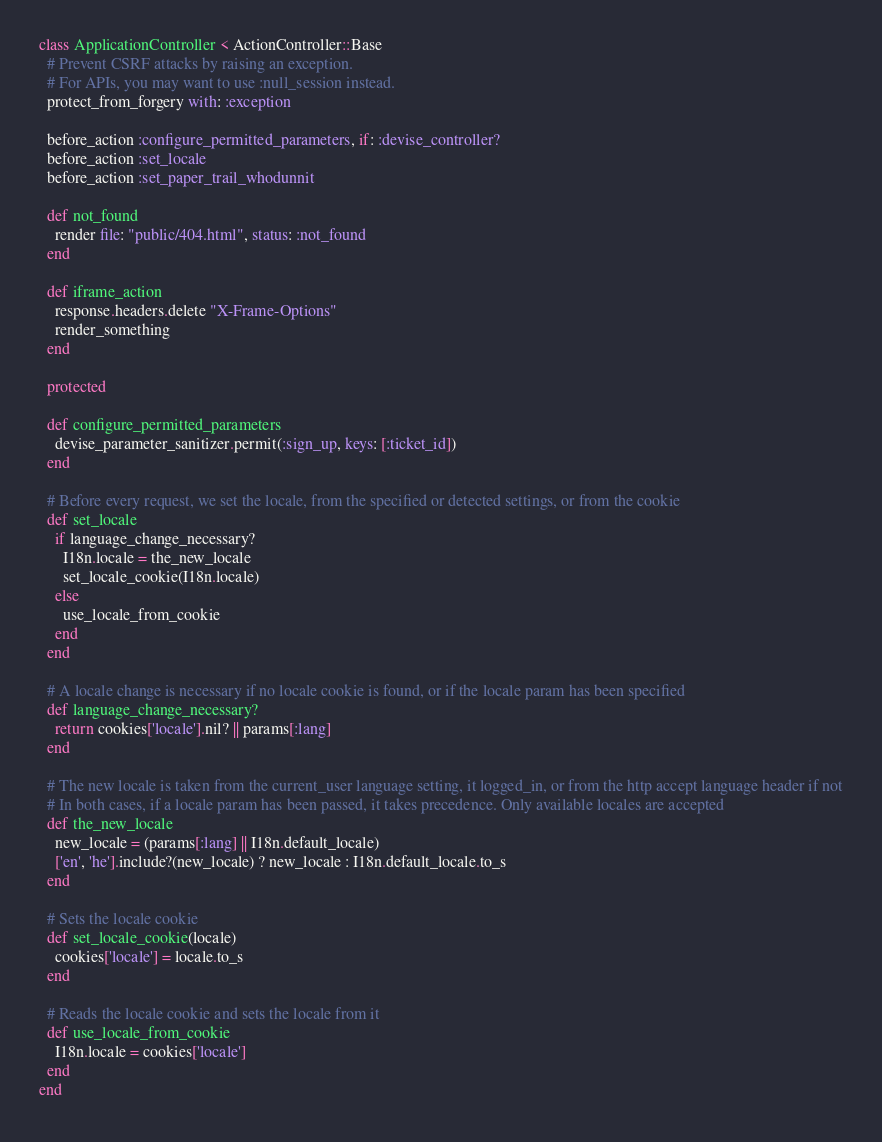<code> <loc_0><loc_0><loc_500><loc_500><_Ruby_>class ApplicationController < ActionController::Base
  # Prevent CSRF attacks by raising an exception.
  # For APIs, you may want to use :null_session instead.
  protect_from_forgery with: :exception

  before_action :configure_permitted_parameters, if: :devise_controller?
  before_action :set_locale
  before_action :set_paper_trail_whodunnit

  def not_found
    render file: "public/404.html", status: :not_found
  end

  def iframe_action
    response.headers.delete "X-Frame-Options"
    render_something
  end
  
  protected

  def configure_permitted_parameters
    devise_parameter_sanitizer.permit(:sign_up, keys: [:ticket_id])
  end
  
  # Before every request, we set the locale, from the specified or detected settings, or from the cookie
  def set_locale
    if language_change_necessary?
      I18n.locale = the_new_locale
      set_locale_cookie(I18n.locale)
    else
      use_locale_from_cookie
    end
  end

  # A locale change is necessary if no locale cookie is found, or if the locale param has been specified
  def language_change_necessary?
    return cookies['locale'].nil? || params[:lang]
  end

  # The new locale is taken from the current_user language setting, it logged_in, or from the http accept language header if not
  # In both cases, if a locale param has been passed, it takes precedence. Only available locales are accepted
  def the_new_locale
    new_locale = (params[:lang] || I18n.default_locale)
    ['en', 'he'].include?(new_locale) ? new_locale : I18n.default_locale.to_s
  end

  # Sets the locale cookie
  def set_locale_cookie(locale)
    cookies['locale'] = locale.to_s
  end

  # Reads the locale cookie and sets the locale from it
  def use_locale_from_cookie
    I18n.locale = cookies['locale']
  end
end
</code> 